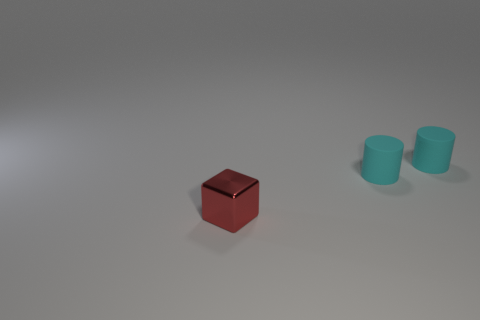Are there any big matte things?
Ensure brevity in your answer.  No. What number of objects are small blue matte blocks or small things that are behind the small red thing?
Provide a succinct answer. 2. The small red thing is what shape?
Your answer should be very brief. Cube. How many other things are there of the same material as the tiny cube?
Offer a very short reply. 0. Are there any other tiny matte things that have the same shape as the tiny red object?
Keep it short and to the point. No. What number of blocks have the same size as the metal object?
Your answer should be very brief. 0. Is the number of metallic balls greater than the number of tiny things?
Provide a short and direct response. No. Are there fewer red shiny things than cyan cylinders?
Your answer should be very brief. Yes. What number of gray things are small things or cylinders?
Provide a short and direct response. 0. Is there any other thing that is the same shape as the red shiny object?
Your response must be concise. No. 